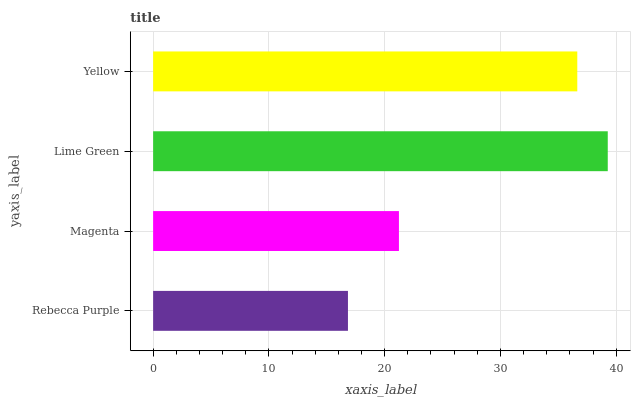Is Rebecca Purple the minimum?
Answer yes or no. Yes. Is Lime Green the maximum?
Answer yes or no. Yes. Is Magenta the minimum?
Answer yes or no. No. Is Magenta the maximum?
Answer yes or no. No. Is Magenta greater than Rebecca Purple?
Answer yes or no. Yes. Is Rebecca Purple less than Magenta?
Answer yes or no. Yes. Is Rebecca Purple greater than Magenta?
Answer yes or no. No. Is Magenta less than Rebecca Purple?
Answer yes or no. No. Is Yellow the high median?
Answer yes or no. Yes. Is Magenta the low median?
Answer yes or no. Yes. Is Lime Green the high median?
Answer yes or no. No. Is Yellow the low median?
Answer yes or no. No. 